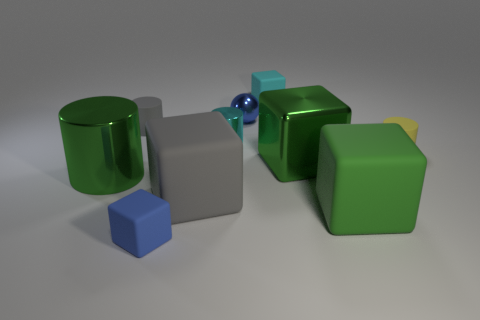Subtract all small blue blocks. How many blocks are left? 4 Subtract all cyan blocks. How many blocks are left? 4 Subtract all brown cubes. Subtract all cyan cylinders. How many cubes are left? 5 Subtract all cylinders. How many objects are left? 6 Add 6 yellow things. How many yellow things exist? 7 Subtract 0 purple cubes. How many objects are left? 10 Subtract all brown shiny spheres. Subtract all metal spheres. How many objects are left? 9 Add 1 big cylinders. How many big cylinders are left? 2 